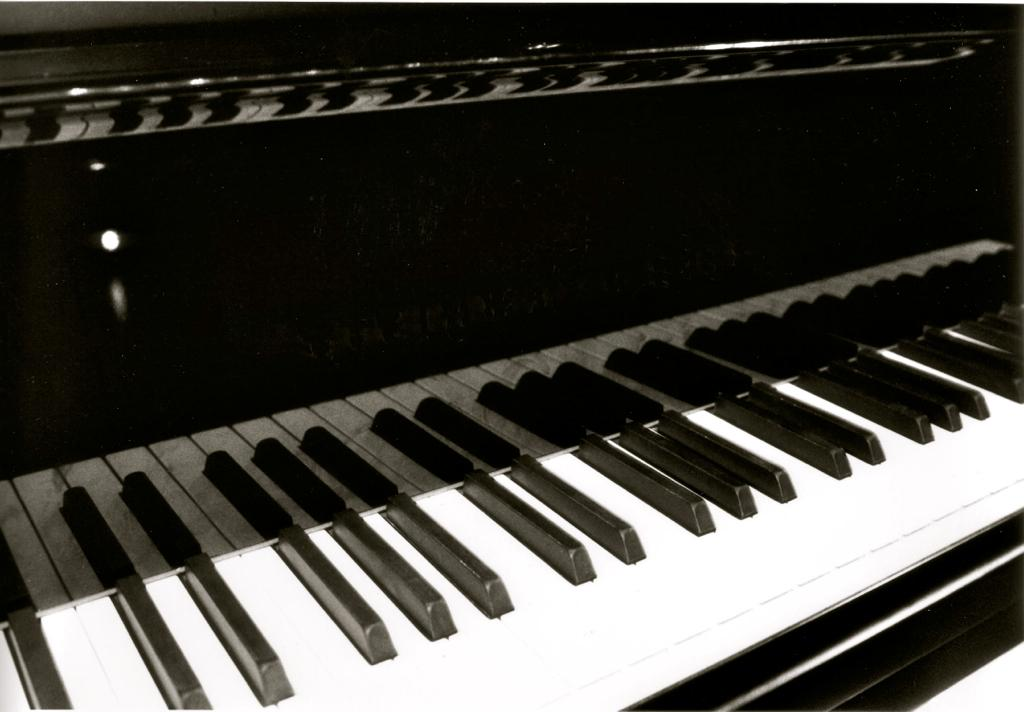What is the main object in the image? There is a piano in the image. How many pizzas are being delivered to the car in the image? There are no pizzas or cars present in the image; it only features a piano. What type of comfort does the piano provide in the image? The image does not convey any information about the comfort provided by the piano. 